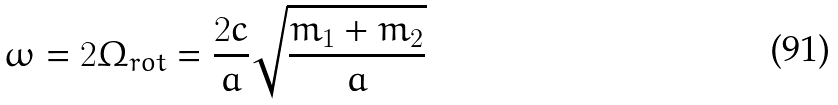Convert formula to latex. <formula><loc_0><loc_0><loc_500><loc_500>\omega = 2 \Omega _ { r o t } = \frac { 2 c } { a } \sqrt { \frac { m _ { 1 } + m _ { 2 } } { a } }</formula> 